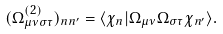<formula> <loc_0><loc_0><loc_500><loc_500>( { \Omega } ^ { ( 2 ) } _ { \mu \nu \sigma \tau } ) _ { n n ^ { \prime } } = \langle \chi _ { n } | \Omega _ { \mu \nu } \Omega _ { \sigma \tau } \chi _ { n ^ { \prime } } \rangle .</formula> 